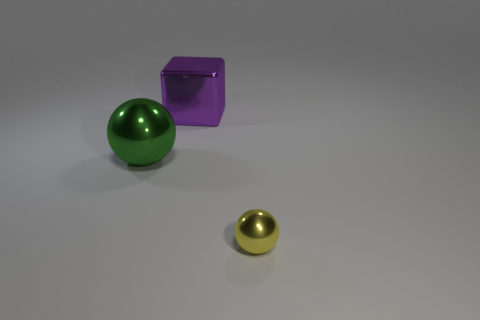Add 1 small balls. How many objects exist? 4 Subtract all green balls. How many balls are left? 1 Subtract 1 spheres. How many spheres are left? 1 Subtract all spheres. How many objects are left? 1 Subtract all green spheres. Subtract all blue cubes. How many spheres are left? 1 Subtract all cyan cylinders. How many green balls are left? 1 Subtract all small shiny spheres. Subtract all big purple objects. How many objects are left? 1 Add 3 metallic things. How many metallic things are left? 6 Add 2 big cyan metallic blocks. How many big cyan metallic blocks exist? 2 Subtract 0 purple balls. How many objects are left? 3 